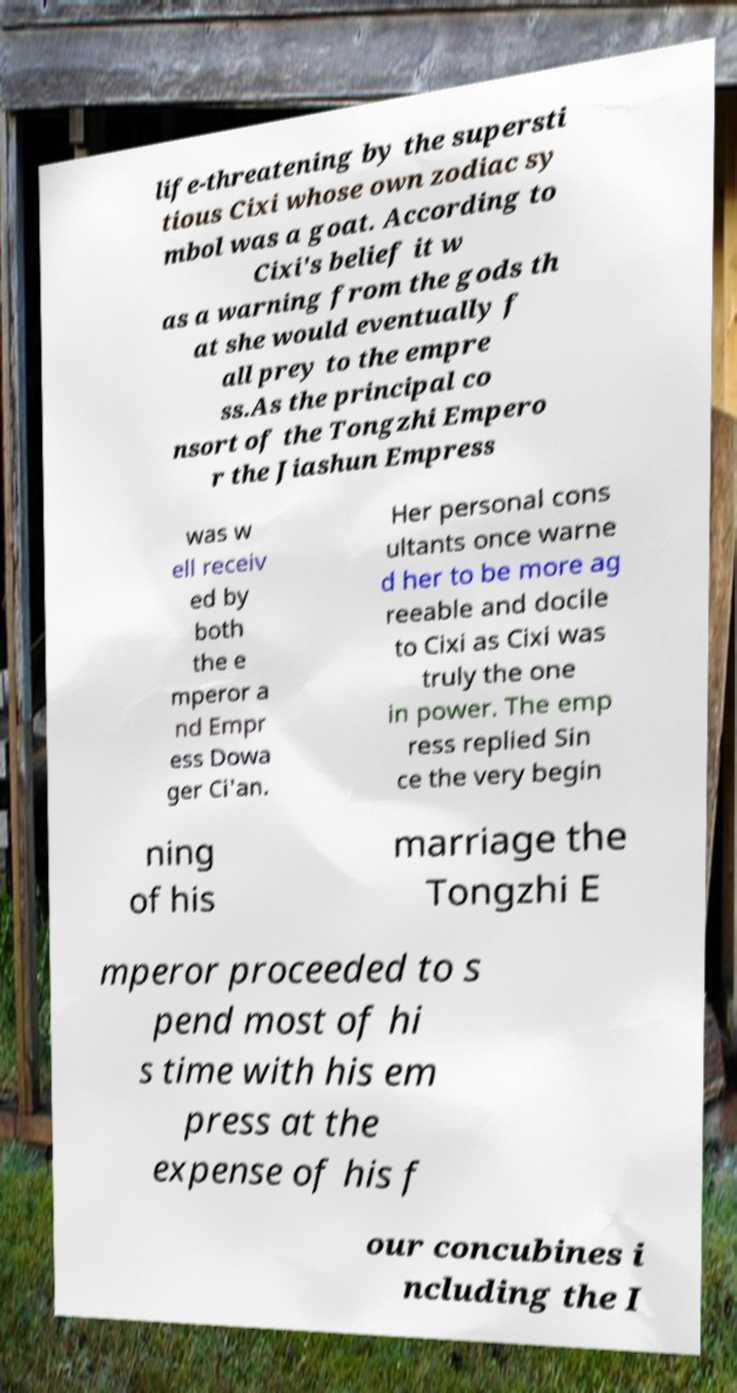Can you accurately transcribe the text from the provided image for me? life-threatening by the supersti tious Cixi whose own zodiac sy mbol was a goat. According to Cixi's belief it w as a warning from the gods th at she would eventually f all prey to the empre ss.As the principal co nsort of the Tongzhi Empero r the Jiashun Empress was w ell receiv ed by both the e mperor a nd Empr ess Dowa ger Ci'an. Her personal cons ultants once warne d her to be more ag reeable and docile to Cixi as Cixi was truly the one in power. The emp ress replied Sin ce the very begin ning of his marriage the Tongzhi E mperor proceeded to s pend most of hi s time with his em press at the expense of his f our concubines i ncluding the I 